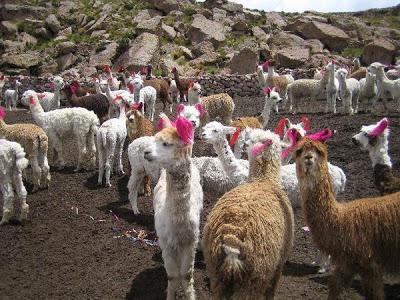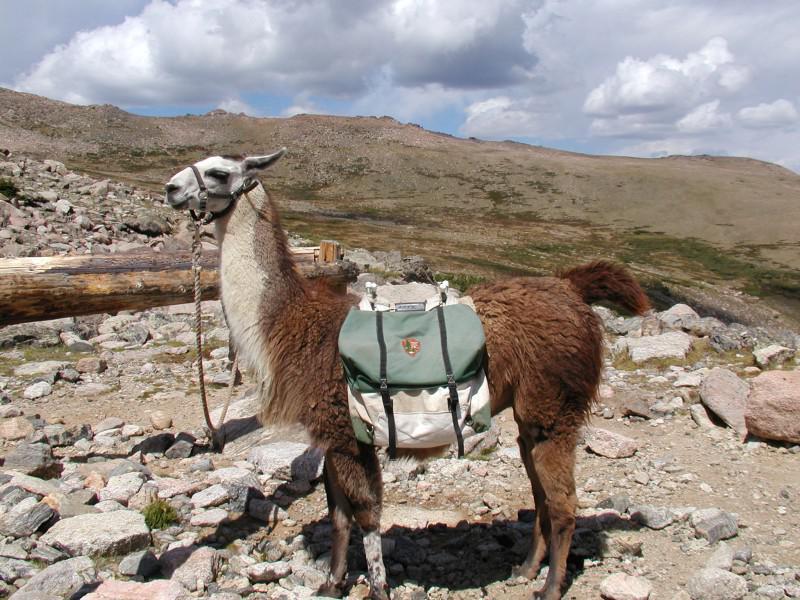The first image is the image on the left, the second image is the image on the right. Assess this claim about the two images: "In one of the images the llamas are facing downhill.". Correct or not? Answer yes or no. No. 